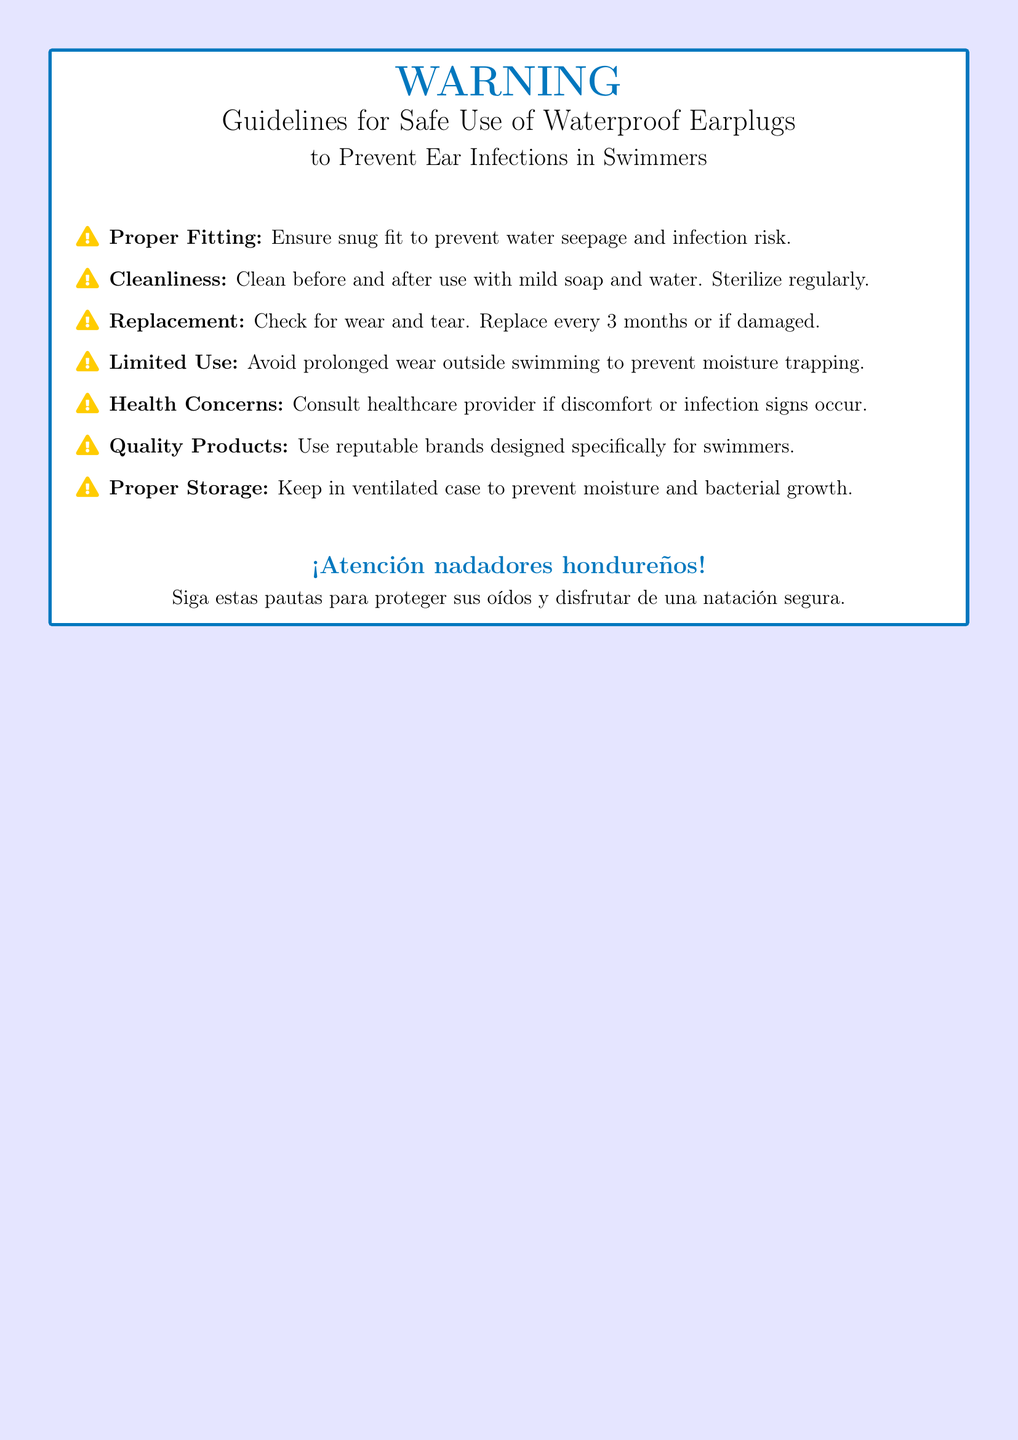What is the main purpose of the document? The document aims to provide guidelines for safe use of waterproof earplugs to prevent ear infections in swimmers.
Answer: Prevent ear infections What should earplugs be checked for? The document advises checking for wear and tear to ensure safety and effectiveness.
Answer: Wear and tear How often should earplugs be replaced? According to the guidelines, earplugs should be replaced every three months or if damaged.
Answer: Every 3 months What should be done to earplugs before and after use? The guidelines specify cleaning with mild soap and water before and after use to maintain hygiene.
Answer: Clean Who should be consulted if discomfort occurs? The document recommends consulting a healthcare provider if there are any signs of discomfort or infection.
Answer: Healthcare provider What color is the warning label's title text? The document features a title text color that is defined as water blue.
Answer: Water blue How can earplugs be stored to keep them safe? Proper storage requires keeping earplugs in a ventilated case to prevent moisture and bacterial growth.
Answer: Ventilated case What does the document urge Honduran swimmers to do? The document directly addresses Honduran swimmers, urging them to follow the given guidelines for safety.
Answer: Follow these guidelines What is recommended to ensure a proper fit of earplugs? Ensuring a snug fit is recommended to prevent water seepage and minimize infection risk.
Answer: Snug fit 